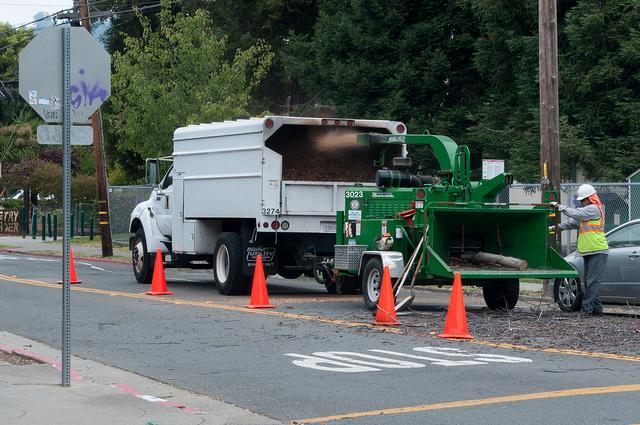How were the purple characters written?

Choices:
A) spray can
B) paintbrush
C) crayon
D) pen spray can 